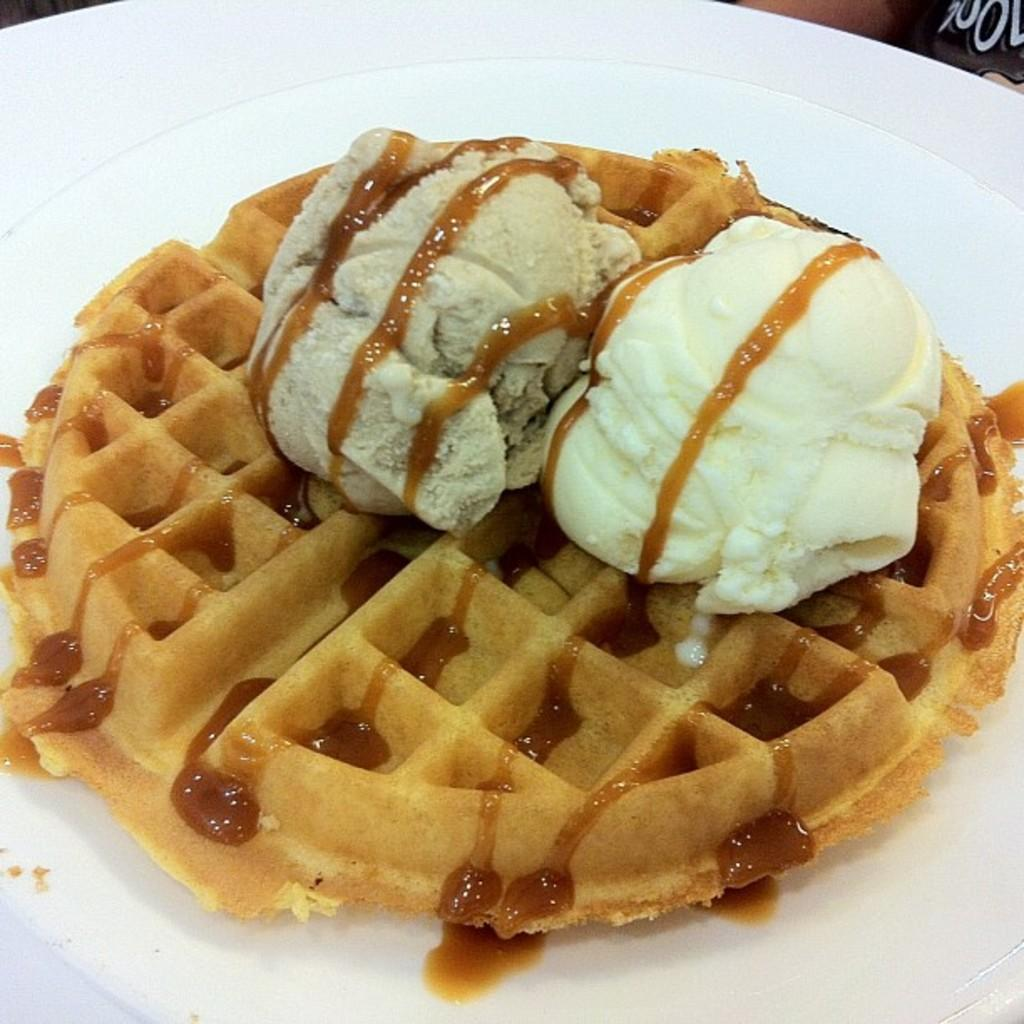What type of food is in the image? There is a Belgian waffle in the image. Where is the Belgian waffle located? The Belgian waffle is in a plate. What type of sofa can be seen in the image? There is no sofa present in the image; it only features a Belgian waffle in a plate. Are there any dinosaurs visible in the image? No, there are no dinosaurs present in the image. 